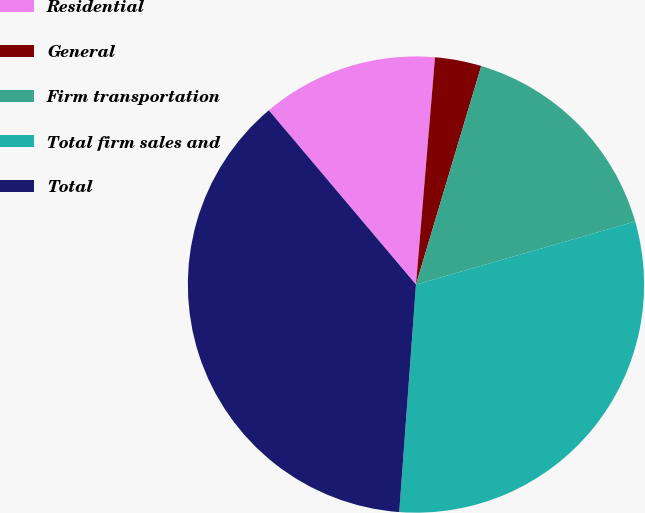Convert chart to OTSL. <chart><loc_0><loc_0><loc_500><loc_500><pie_chart><fcel>Residential<fcel>General<fcel>Firm transportation<fcel>Total firm sales and<fcel>Total<nl><fcel>12.49%<fcel>3.29%<fcel>15.92%<fcel>30.63%<fcel>37.67%<nl></chart> 